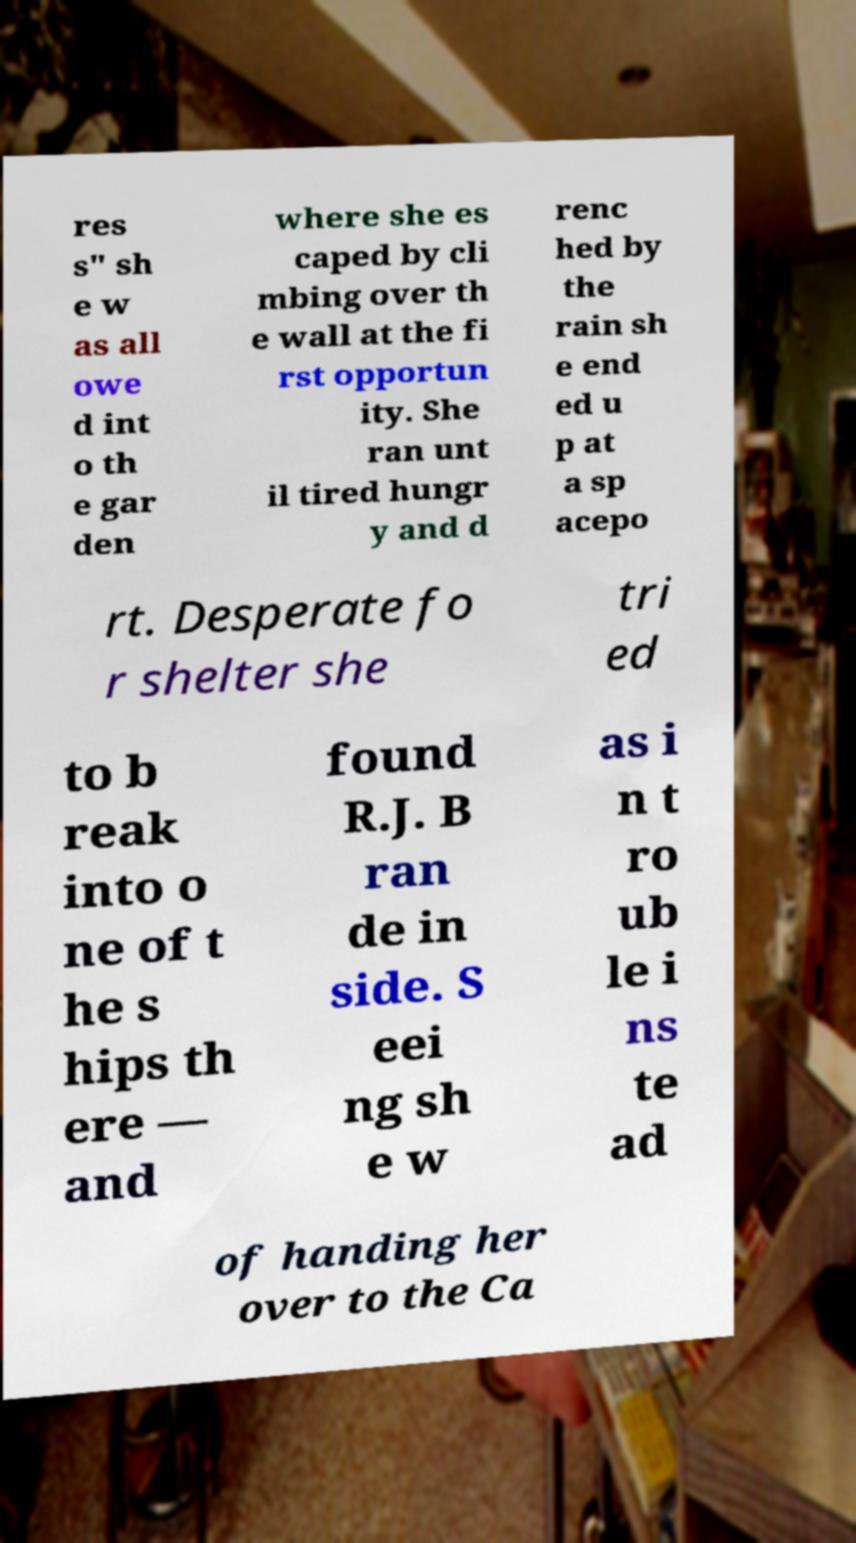Can you accurately transcribe the text from the provided image for me? res s" sh e w as all owe d int o th e gar den where she es caped by cli mbing over th e wall at the fi rst opportun ity. She ran unt il tired hungr y and d renc hed by the rain sh e end ed u p at a sp acepo rt. Desperate fo r shelter she tri ed to b reak into o ne of t he s hips th ere — and found R.J. B ran de in side. S eei ng sh e w as i n t ro ub le i ns te ad of handing her over to the Ca 